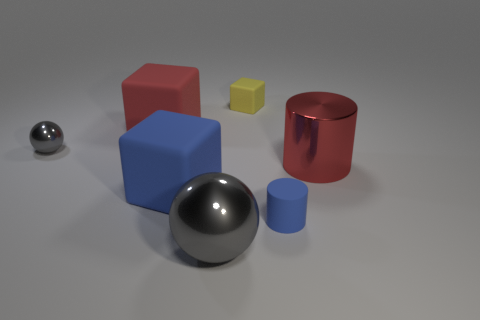There is a gray thing that is behind the large gray shiny ball; what shape is it?
Your answer should be very brief. Sphere. Does the red cube have the same material as the blue thing behind the blue matte cylinder?
Make the answer very short. Yes. How many other things are the same shape as the large red metal thing?
Ensure brevity in your answer.  1. There is a small matte block; is its color the same as the tiny object to the left of the small cube?
Offer a very short reply. No. There is a tiny thing in front of the big rubber thing that is in front of the small metallic ball; what is its shape?
Your response must be concise. Cylinder. The thing that is the same color as the large ball is what size?
Your answer should be compact. Small. Do the blue thing to the left of the tiny yellow rubber thing and the large gray shiny thing have the same shape?
Your response must be concise. No. Is the number of rubber things behind the small blue thing greater than the number of balls that are behind the large shiny cylinder?
Your answer should be very brief. Yes. How many small blocks are behind the cylinder that is to the left of the red cylinder?
Offer a terse response. 1. What is the material of the tiny ball that is the same color as the big sphere?
Make the answer very short. Metal. 